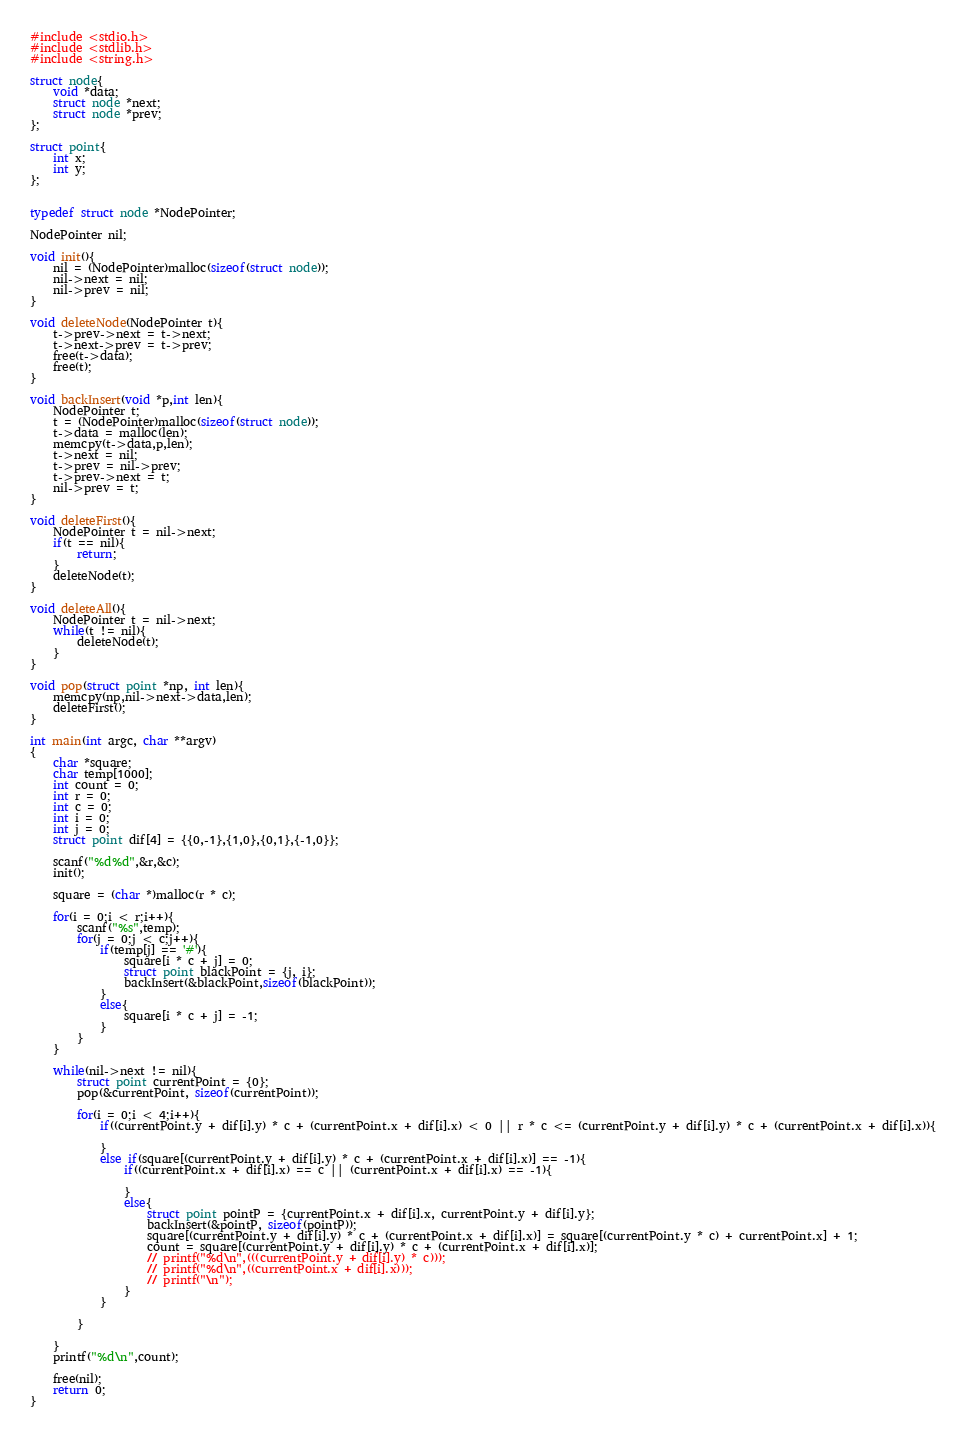Convert code to text. <code><loc_0><loc_0><loc_500><loc_500><_C_>#include <stdio.h>
#include <stdlib.h>
#include <string.h>

struct node{
	void *data;
	struct node *next;
	struct node *prev;
};

struct point{
	int x;
	int y;
};


typedef struct node *NodePointer;

NodePointer nil;

void init(){
	nil = (NodePointer)malloc(sizeof(struct node));
	nil->next = nil;
	nil->prev = nil;
}

void deleteNode(NodePointer t){
	t->prev->next = t->next;
	t->next->prev = t->prev;
	free(t->data);
	free(t);
}

void backInsert(void *p,int len){
	NodePointer t;
	t = (NodePointer)malloc(sizeof(struct node));
	t->data = malloc(len);
	memcpy(t->data,p,len);
	t->next = nil;
	t->prev = nil->prev;
	t->prev->next = t;
	nil->prev = t;
}

void deleteFirst(){
	NodePointer t = nil->next;
	if(t == nil){
		return;
	}
	deleteNode(t);
}

void deleteAll(){
	NodePointer t = nil->next;
	while(t != nil){
		deleteNode(t);
	}
}

void pop(struct point *np, int len){
	memcpy(np,nil->next->data,len);
	deleteFirst();
}

int main(int argc, char **argv)
{
	char *square;
	char temp[1000];
	int count = 0;
	int r = 0;
	int c = 0;
	int i = 0;
	int j = 0;
	struct point dif[4] = {{0,-1},{1,0},{0,1},{-1,0}};

	scanf("%d%d",&r,&c);
	init();

	square = (char *)malloc(r * c);
	
	for(i = 0;i < r;i++){
		scanf("%s",temp);
		for(j = 0;j < c;j++){
			if(temp[j] == '#'){
				square[i * c + j] = 0;
				struct point blackPoint = {j, i};
				backInsert(&blackPoint,sizeof(blackPoint));
			}
			else{
				square[i * c + j] = -1;
			}
		}
	}
	
	while(nil->next != nil){
		struct point currentPoint = {0};
		pop(&currentPoint, sizeof(currentPoint));

		for(i = 0;i < 4;i++){
			if((currentPoint.y + dif[i].y) * c + (currentPoint.x + dif[i].x) < 0 || r * c <= (currentPoint.y + dif[i].y) * c + (currentPoint.x + dif[i].x)){

			}
			else if(square[(currentPoint.y + dif[i].y) * c + (currentPoint.x + dif[i].x)] == -1){
				if((currentPoint.x + dif[i].x) == c || (currentPoint.x + dif[i].x) == -1){
					
				}
				else{
					struct point pointP = {currentPoint.x + dif[i].x, currentPoint.y + dif[i].y};
					backInsert(&pointP, sizeof(pointP));
					square[(currentPoint.y + dif[i].y) * c + (currentPoint.x + dif[i].x)] = square[(currentPoint.y * c) + currentPoint.x] + 1;
					count = square[(currentPoint.y + dif[i].y) * c + (currentPoint.x + dif[i].x)];
					// printf("%d\n",(((currentPoint.y + dif[i].y) * c)));
					// printf("%d\n",((currentPoint.x + dif[i].x)));
					// printf("\n");
				}
			}
			
		}
		
	}
	printf("%d\n",count);
	
	free(nil);
	return 0;
}
</code> 